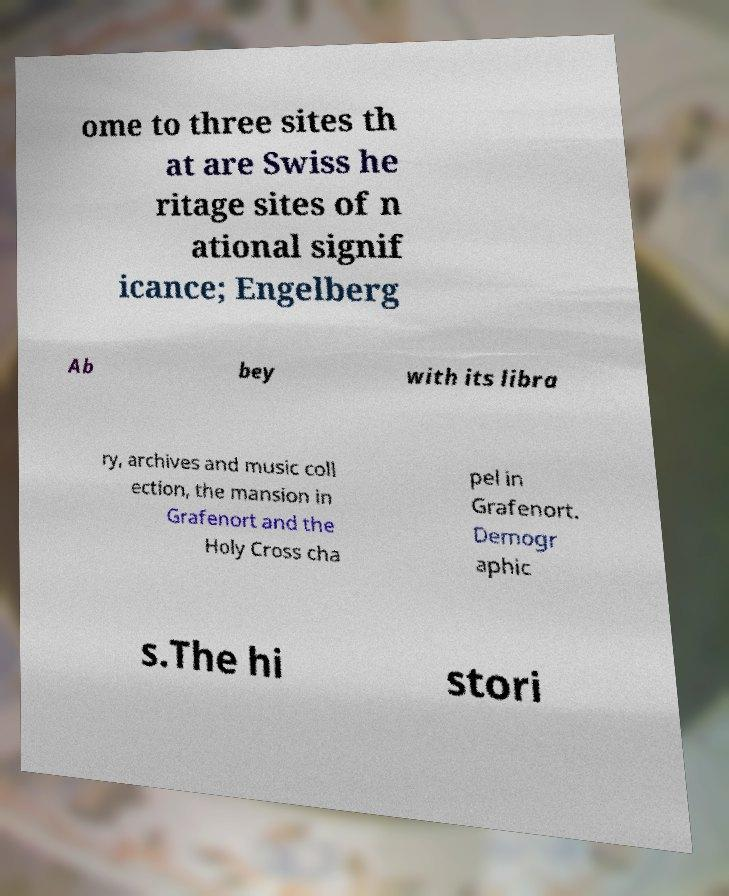There's text embedded in this image that I need extracted. Can you transcribe it verbatim? ome to three sites th at are Swiss he ritage sites of n ational signif icance; Engelberg Ab bey with its libra ry, archives and music coll ection, the mansion in Grafenort and the Holy Cross cha pel in Grafenort. Demogr aphic s.The hi stori 